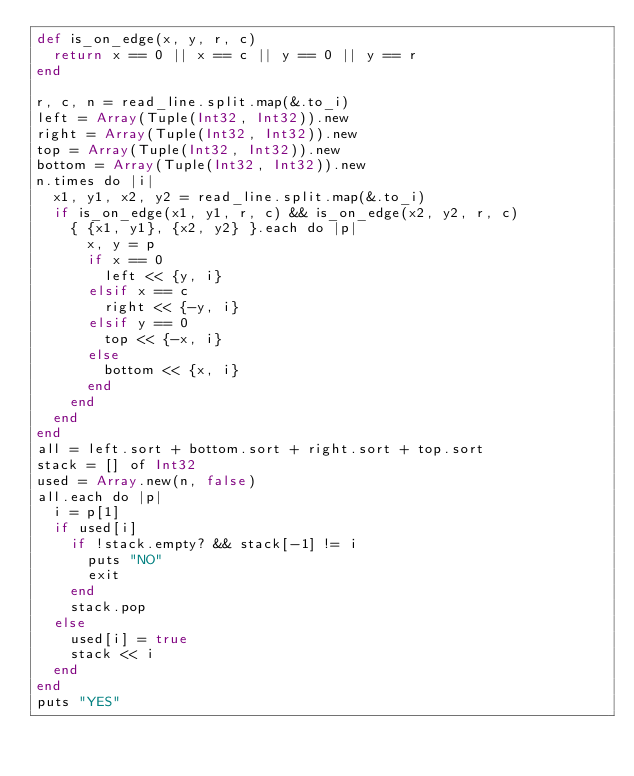Convert code to text. <code><loc_0><loc_0><loc_500><loc_500><_Crystal_>def is_on_edge(x, y, r, c)
  return x == 0 || x == c || y == 0 || y == r
end

r, c, n = read_line.split.map(&.to_i)
left = Array(Tuple(Int32, Int32)).new
right = Array(Tuple(Int32, Int32)).new
top = Array(Tuple(Int32, Int32)).new
bottom = Array(Tuple(Int32, Int32)).new
n.times do |i|
  x1, y1, x2, y2 = read_line.split.map(&.to_i)
  if is_on_edge(x1, y1, r, c) && is_on_edge(x2, y2, r, c)
    { {x1, y1}, {x2, y2} }.each do |p|
      x, y = p
      if x == 0
        left << {y, i}
      elsif x == c
        right << {-y, i}
      elsif y == 0
        top << {-x, i}
      else
        bottom << {x, i}
      end
    end
  end
end
all = left.sort + bottom.sort + right.sort + top.sort
stack = [] of Int32
used = Array.new(n, false)
all.each do |p|
  i = p[1]
  if used[i]
    if !stack.empty? && stack[-1] != i
      puts "NO"
      exit
    end
    stack.pop
  else
    used[i] = true
    stack << i
  end
end
puts "YES"
</code> 